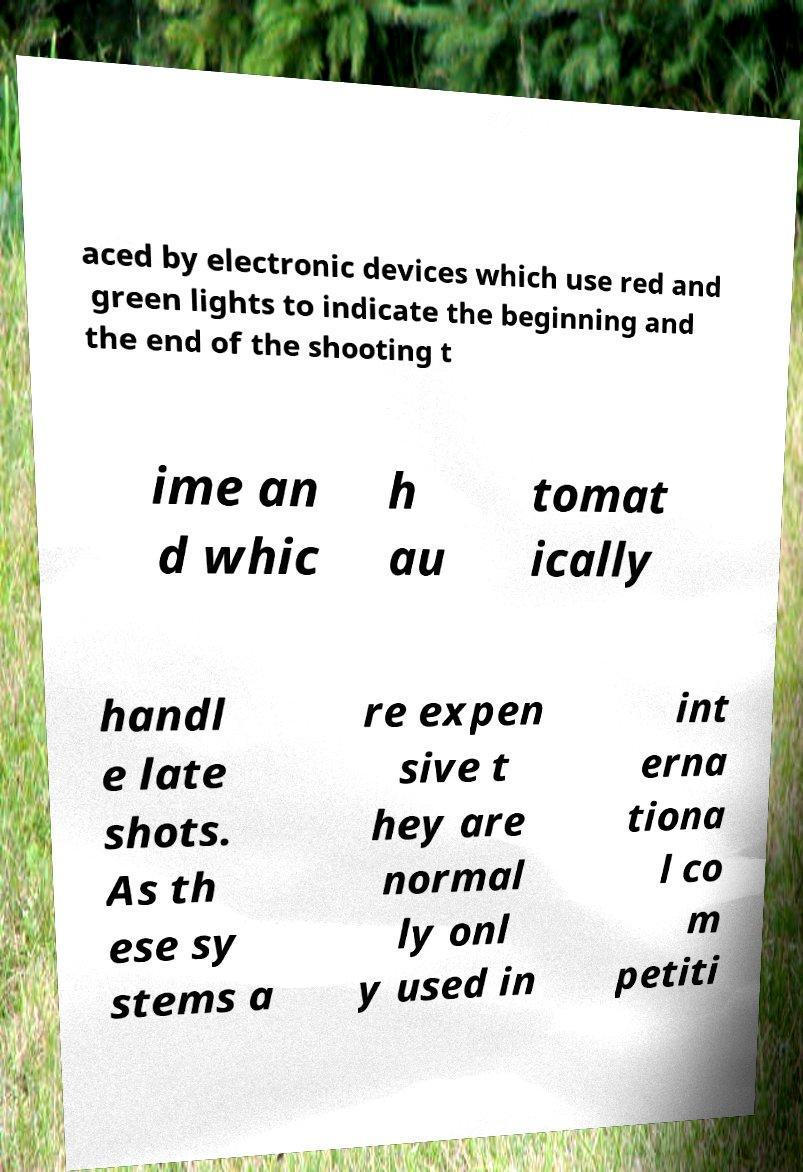What messages or text are displayed in this image? I need them in a readable, typed format. aced by electronic devices which use red and green lights to indicate the beginning and the end of the shooting t ime an d whic h au tomat ically handl e late shots. As th ese sy stems a re expen sive t hey are normal ly onl y used in int erna tiona l co m petiti 